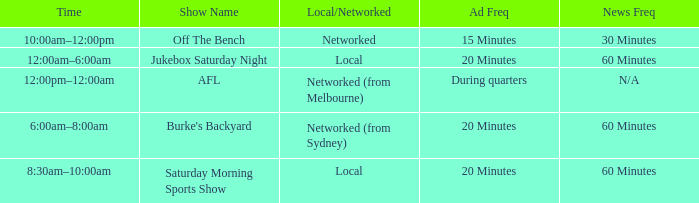What is the local/network with an Ad frequency of 15 minutes? Networked. 